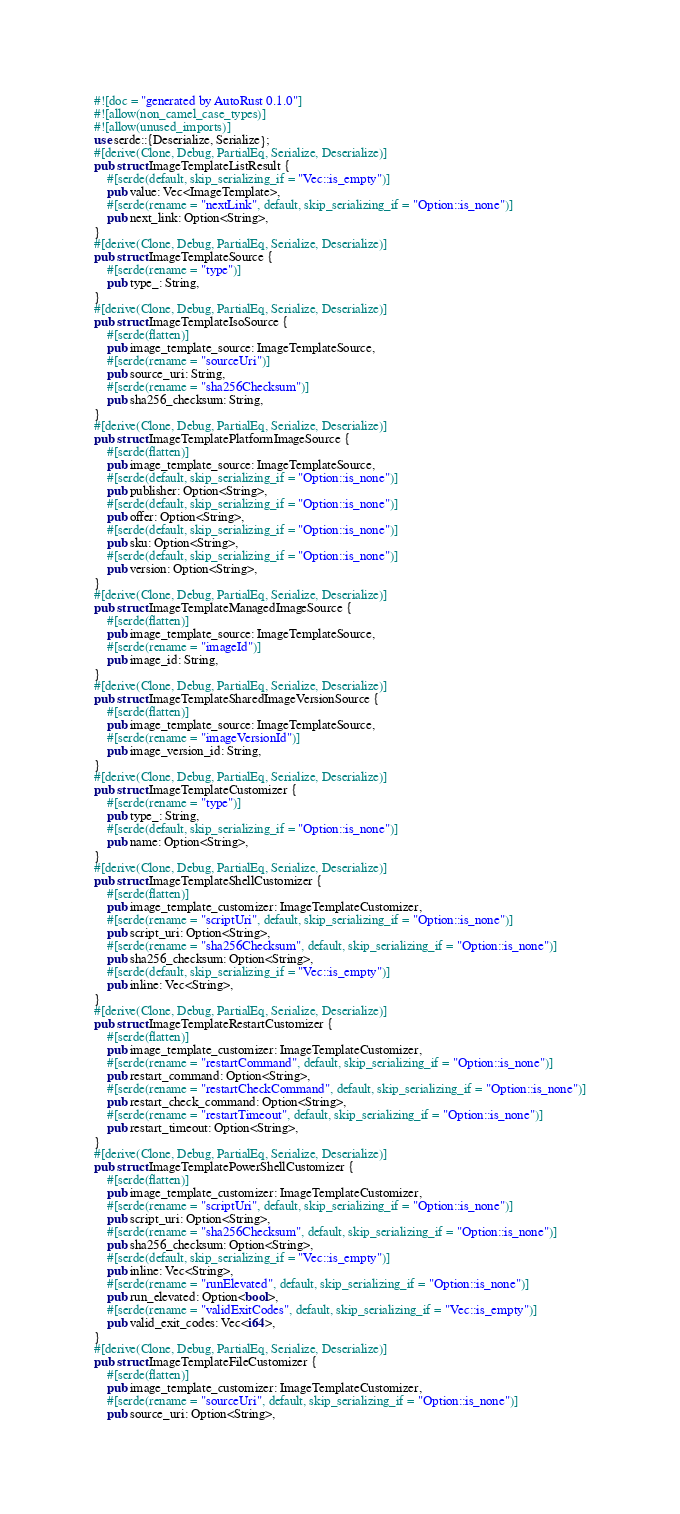Convert code to text. <code><loc_0><loc_0><loc_500><loc_500><_Rust_>#![doc = "generated by AutoRust 0.1.0"]
#![allow(non_camel_case_types)]
#![allow(unused_imports)]
use serde::{Deserialize, Serialize};
#[derive(Clone, Debug, PartialEq, Serialize, Deserialize)]
pub struct ImageTemplateListResult {
    #[serde(default, skip_serializing_if = "Vec::is_empty")]
    pub value: Vec<ImageTemplate>,
    #[serde(rename = "nextLink", default, skip_serializing_if = "Option::is_none")]
    pub next_link: Option<String>,
}
#[derive(Clone, Debug, PartialEq, Serialize, Deserialize)]
pub struct ImageTemplateSource {
    #[serde(rename = "type")]
    pub type_: String,
}
#[derive(Clone, Debug, PartialEq, Serialize, Deserialize)]
pub struct ImageTemplateIsoSource {
    #[serde(flatten)]
    pub image_template_source: ImageTemplateSource,
    #[serde(rename = "sourceUri")]
    pub source_uri: String,
    #[serde(rename = "sha256Checksum")]
    pub sha256_checksum: String,
}
#[derive(Clone, Debug, PartialEq, Serialize, Deserialize)]
pub struct ImageTemplatePlatformImageSource {
    #[serde(flatten)]
    pub image_template_source: ImageTemplateSource,
    #[serde(default, skip_serializing_if = "Option::is_none")]
    pub publisher: Option<String>,
    #[serde(default, skip_serializing_if = "Option::is_none")]
    pub offer: Option<String>,
    #[serde(default, skip_serializing_if = "Option::is_none")]
    pub sku: Option<String>,
    #[serde(default, skip_serializing_if = "Option::is_none")]
    pub version: Option<String>,
}
#[derive(Clone, Debug, PartialEq, Serialize, Deserialize)]
pub struct ImageTemplateManagedImageSource {
    #[serde(flatten)]
    pub image_template_source: ImageTemplateSource,
    #[serde(rename = "imageId")]
    pub image_id: String,
}
#[derive(Clone, Debug, PartialEq, Serialize, Deserialize)]
pub struct ImageTemplateSharedImageVersionSource {
    #[serde(flatten)]
    pub image_template_source: ImageTemplateSource,
    #[serde(rename = "imageVersionId")]
    pub image_version_id: String,
}
#[derive(Clone, Debug, PartialEq, Serialize, Deserialize)]
pub struct ImageTemplateCustomizer {
    #[serde(rename = "type")]
    pub type_: String,
    #[serde(default, skip_serializing_if = "Option::is_none")]
    pub name: Option<String>,
}
#[derive(Clone, Debug, PartialEq, Serialize, Deserialize)]
pub struct ImageTemplateShellCustomizer {
    #[serde(flatten)]
    pub image_template_customizer: ImageTemplateCustomizer,
    #[serde(rename = "scriptUri", default, skip_serializing_if = "Option::is_none")]
    pub script_uri: Option<String>,
    #[serde(rename = "sha256Checksum", default, skip_serializing_if = "Option::is_none")]
    pub sha256_checksum: Option<String>,
    #[serde(default, skip_serializing_if = "Vec::is_empty")]
    pub inline: Vec<String>,
}
#[derive(Clone, Debug, PartialEq, Serialize, Deserialize)]
pub struct ImageTemplateRestartCustomizer {
    #[serde(flatten)]
    pub image_template_customizer: ImageTemplateCustomizer,
    #[serde(rename = "restartCommand", default, skip_serializing_if = "Option::is_none")]
    pub restart_command: Option<String>,
    #[serde(rename = "restartCheckCommand", default, skip_serializing_if = "Option::is_none")]
    pub restart_check_command: Option<String>,
    #[serde(rename = "restartTimeout", default, skip_serializing_if = "Option::is_none")]
    pub restart_timeout: Option<String>,
}
#[derive(Clone, Debug, PartialEq, Serialize, Deserialize)]
pub struct ImageTemplatePowerShellCustomizer {
    #[serde(flatten)]
    pub image_template_customizer: ImageTemplateCustomizer,
    #[serde(rename = "scriptUri", default, skip_serializing_if = "Option::is_none")]
    pub script_uri: Option<String>,
    #[serde(rename = "sha256Checksum", default, skip_serializing_if = "Option::is_none")]
    pub sha256_checksum: Option<String>,
    #[serde(default, skip_serializing_if = "Vec::is_empty")]
    pub inline: Vec<String>,
    #[serde(rename = "runElevated", default, skip_serializing_if = "Option::is_none")]
    pub run_elevated: Option<bool>,
    #[serde(rename = "validExitCodes", default, skip_serializing_if = "Vec::is_empty")]
    pub valid_exit_codes: Vec<i64>,
}
#[derive(Clone, Debug, PartialEq, Serialize, Deserialize)]
pub struct ImageTemplateFileCustomizer {
    #[serde(flatten)]
    pub image_template_customizer: ImageTemplateCustomizer,
    #[serde(rename = "sourceUri", default, skip_serializing_if = "Option::is_none")]
    pub source_uri: Option<String>,</code> 